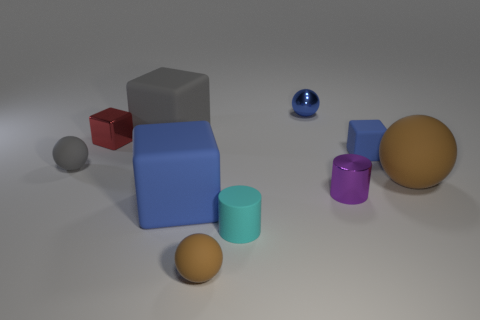What is the size of the matte thing that is on the left side of the small cyan thing and in front of the large blue block?
Make the answer very short. Small. How many small red blocks have the same material as the blue ball?
Your answer should be very brief. 1. What number of balls are either rubber objects or big gray matte things?
Make the answer very short. 3. What is the size of the brown matte ball right of the small rubber sphere on the right side of the gray thing that is behind the gray rubber sphere?
Provide a short and direct response. Large. There is a tiny metallic object that is both in front of the big gray cube and on the left side of the shiny cylinder; what is its color?
Your answer should be very brief. Red. There is a red block; is its size the same as the sphere that is behind the small red shiny object?
Make the answer very short. Yes. Is there anything else that has the same shape as the large blue thing?
Your answer should be compact. Yes. There is a metallic thing that is the same shape as the tiny cyan rubber thing; what color is it?
Offer a terse response. Purple. Do the gray block and the cyan matte object have the same size?
Your response must be concise. No. How many other objects are the same size as the purple shiny cylinder?
Your answer should be compact. 6. 